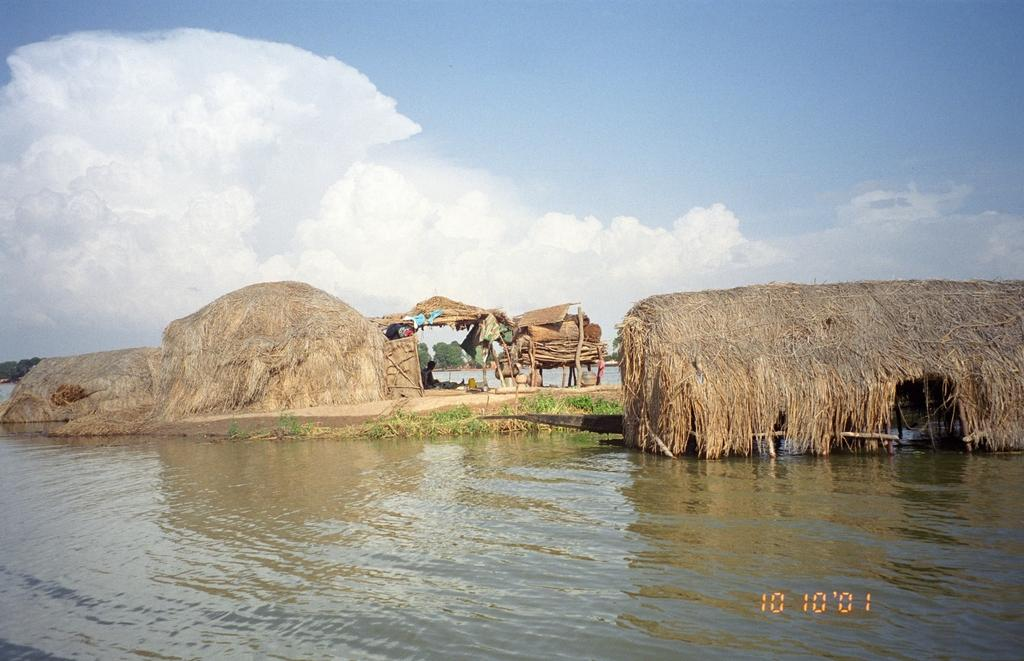What is present on the ground in the image? There are objects on the ground in the image. What natural element can be seen in the image? There is water visible in the image. What is visible in the background of the image? The sky is visible in the background of the image. Is there any additional information about the image itself? Yes, there is a watermark on the image. How many trains can be seen in the image? There are no trains present in the image. What is the value of the cent in the image? There is no cent present in the image. 